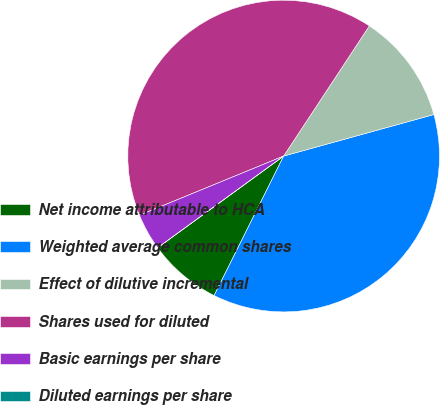Convert chart. <chart><loc_0><loc_0><loc_500><loc_500><pie_chart><fcel>Net income attributable to HCA<fcel>Weighted average common shares<fcel>Effect of dilutive incremental<fcel>Shares used for diluted<fcel>Basic earnings per share<fcel>Diluted earnings per share<nl><fcel>7.63%<fcel>36.65%<fcel>11.44%<fcel>40.46%<fcel>3.81%<fcel>0.0%<nl></chart> 